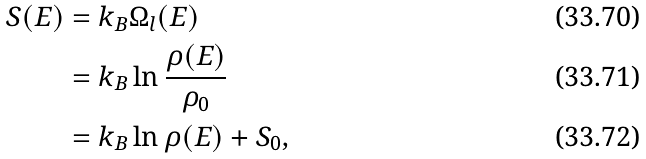Convert formula to latex. <formula><loc_0><loc_0><loc_500><loc_500>S ( E ) & = k _ { B } \Omega _ { l } ( E ) \\ & = k _ { B } \ln \frac { \rho ( E ) } { \rho _ { 0 } } \\ & = k _ { B } \ln \rho ( E ) + S _ { 0 } ,</formula> 